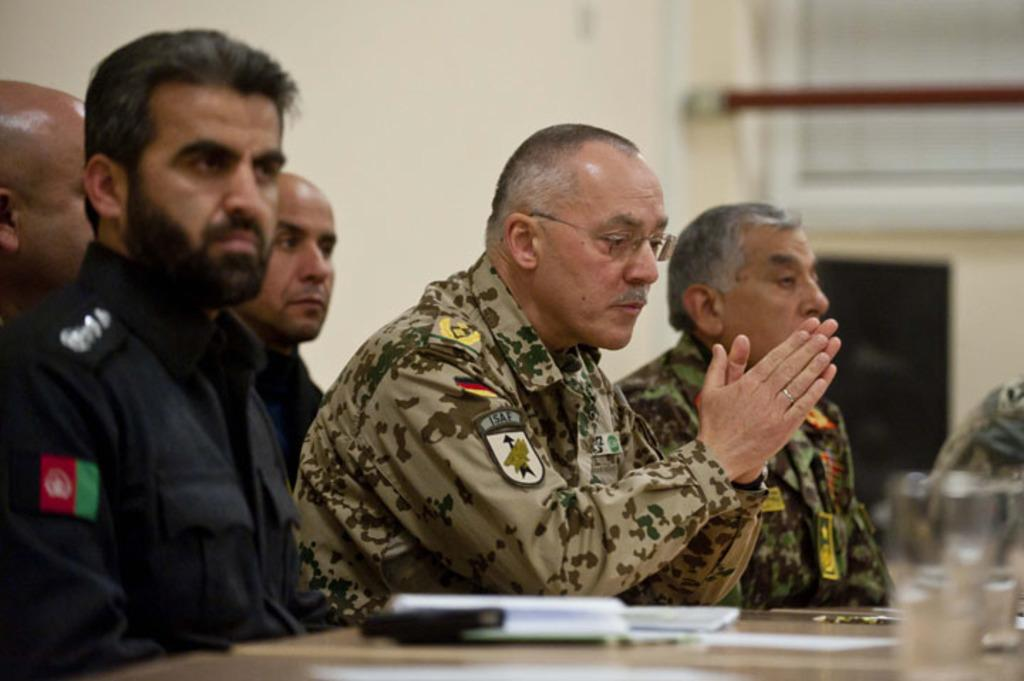What type of people are in the image? There are military men in the image. What are the military men doing in the image? The military men are sitting on chairs and listening. What is on the table in the image? There is a water glass and white papers on the table. What can be seen in the background of the image? There is a white wall in the background. What color is the zebra's hair in the image? There is no zebra present in the image, so we cannot determine the color of its hair. How many cherries are on the white papers in the image? There are no cherries present in the image; only a water glass and white papers are on the table. 